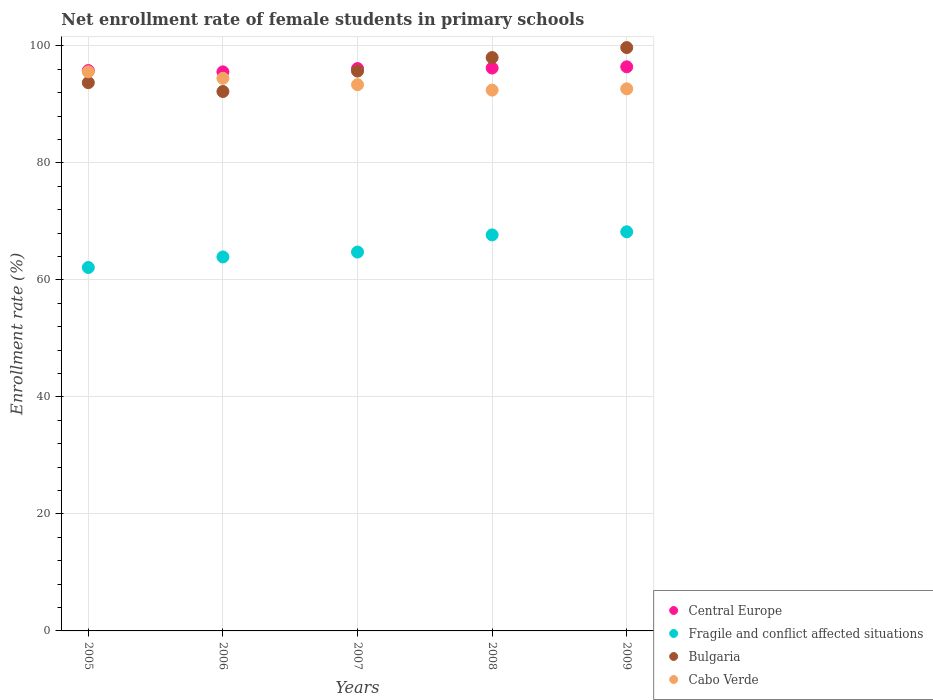How many different coloured dotlines are there?
Offer a terse response. 4. Is the number of dotlines equal to the number of legend labels?
Ensure brevity in your answer.  Yes. What is the net enrollment rate of female students in primary schools in Cabo Verde in 2007?
Ensure brevity in your answer.  93.38. Across all years, what is the maximum net enrollment rate of female students in primary schools in Cabo Verde?
Make the answer very short. 95.59. Across all years, what is the minimum net enrollment rate of female students in primary schools in Cabo Verde?
Your response must be concise. 92.46. In which year was the net enrollment rate of female students in primary schools in Cabo Verde maximum?
Offer a terse response. 2005. What is the total net enrollment rate of female students in primary schools in Bulgaria in the graph?
Your response must be concise. 479.41. What is the difference between the net enrollment rate of female students in primary schools in Cabo Verde in 2006 and that in 2009?
Provide a short and direct response. 1.81. What is the difference between the net enrollment rate of female students in primary schools in Central Europe in 2006 and the net enrollment rate of female students in primary schools in Bulgaria in 2008?
Your response must be concise. -2.45. What is the average net enrollment rate of female students in primary schools in Bulgaria per year?
Keep it short and to the point. 95.88. In the year 2005, what is the difference between the net enrollment rate of female students in primary schools in Cabo Verde and net enrollment rate of female students in primary schools in Central Europe?
Ensure brevity in your answer.  -0.21. What is the ratio of the net enrollment rate of female students in primary schools in Cabo Verde in 2008 to that in 2009?
Keep it short and to the point. 1. Is the difference between the net enrollment rate of female students in primary schools in Cabo Verde in 2005 and 2008 greater than the difference between the net enrollment rate of female students in primary schools in Central Europe in 2005 and 2008?
Offer a very short reply. Yes. What is the difference between the highest and the second highest net enrollment rate of female students in primary schools in Cabo Verde?
Give a very brief answer. 1.11. What is the difference between the highest and the lowest net enrollment rate of female students in primary schools in Fragile and conflict affected situations?
Ensure brevity in your answer.  6.1. Is the net enrollment rate of female students in primary schools in Fragile and conflict affected situations strictly less than the net enrollment rate of female students in primary schools in Bulgaria over the years?
Keep it short and to the point. Yes. How many dotlines are there?
Keep it short and to the point. 4. How many years are there in the graph?
Ensure brevity in your answer.  5. What is the difference between two consecutive major ticks on the Y-axis?
Provide a short and direct response. 20. Are the values on the major ticks of Y-axis written in scientific E-notation?
Ensure brevity in your answer.  No. Does the graph contain any zero values?
Your response must be concise. No. How are the legend labels stacked?
Offer a terse response. Vertical. What is the title of the graph?
Provide a succinct answer. Net enrollment rate of female students in primary schools. Does "Low & middle income" appear as one of the legend labels in the graph?
Your answer should be very brief. No. What is the label or title of the Y-axis?
Your response must be concise. Enrollment rate (%). What is the Enrollment rate (%) of Central Europe in 2005?
Keep it short and to the point. 95.8. What is the Enrollment rate (%) in Fragile and conflict affected situations in 2005?
Provide a succinct answer. 62.13. What is the Enrollment rate (%) of Bulgaria in 2005?
Keep it short and to the point. 93.73. What is the Enrollment rate (%) of Cabo Verde in 2005?
Give a very brief answer. 95.59. What is the Enrollment rate (%) in Central Europe in 2006?
Your answer should be compact. 95.57. What is the Enrollment rate (%) of Fragile and conflict affected situations in 2006?
Provide a succinct answer. 63.93. What is the Enrollment rate (%) in Bulgaria in 2006?
Your answer should be compact. 92.22. What is the Enrollment rate (%) of Cabo Verde in 2006?
Provide a short and direct response. 94.48. What is the Enrollment rate (%) of Central Europe in 2007?
Provide a succinct answer. 96.14. What is the Enrollment rate (%) in Fragile and conflict affected situations in 2007?
Make the answer very short. 64.77. What is the Enrollment rate (%) in Bulgaria in 2007?
Keep it short and to the point. 95.71. What is the Enrollment rate (%) of Cabo Verde in 2007?
Give a very brief answer. 93.38. What is the Enrollment rate (%) of Central Europe in 2008?
Ensure brevity in your answer.  96.23. What is the Enrollment rate (%) of Fragile and conflict affected situations in 2008?
Your answer should be very brief. 67.71. What is the Enrollment rate (%) in Bulgaria in 2008?
Your answer should be very brief. 98.02. What is the Enrollment rate (%) of Cabo Verde in 2008?
Your response must be concise. 92.46. What is the Enrollment rate (%) of Central Europe in 2009?
Your answer should be compact. 96.44. What is the Enrollment rate (%) in Fragile and conflict affected situations in 2009?
Give a very brief answer. 68.23. What is the Enrollment rate (%) in Bulgaria in 2009?
Your answer should be very brief. 99.73. What is the Enrollment rate (%) of Cabo Verde in 2009?
Your answer should be very brief. 92.67. Across all years, what is the maximum Enrollment rate (%) in Central Europe?
Provide a short and direct response. 96.44. Across all years, what is the maximum Enrollment rate (%) in Fragile and conflict affected situations?
Provide a short and direct response. 68.23. Across all years, what is the maximum Enrollment rate (%) of Bulgaria?
Provide a succinct answer. 99.73. Across all years, what is the maximum Enrollment rate (%) in Cabo Verde?
Make the answer very short. 95.59. Across all years, what is the minimum Enrollment rate (%) of Central Europe?
Offer a very short reply. 95.57. Across all years, what is the minimum Enrollment rate (%) of Fragile and conflict affected situations?
Your response must be concise. 62.13. Across all years, what is the minimum Enrollment rate (%) of Bulgaria?
Provide a short and direct response. 92.22. Across all years, what is the minimum Enrollment rate (%) of Cabo Verde?
Provide a succinct answer. 92.46. What is the total Enrollment rate (%) of Central Europe in the graph?
Provide a succinct answer. 480.18. What is the total Enrollment rate (%) of Fragile and conflict affected situations in the graph?
Ensure brevity in your answer.  326.78. What is the total Enrollment rate (%) of Bulgaria in the graph?
Your response must be concise. 479.41. What is the total Enrollment rate (%) of Cabo Verde in the graph?
Provide a short and direct response. 468.57. What is the difference between the Enrollment rate (%) in Central Europe in 2005 and that in 2006?
Ensure brevity in your answer.  0.22. What is the difference between the Enrollment rate (%) of Fragile and conflict affected situations in 2005 and that in 2006?
Your answer should be compact. -1.8. What is the difference between the Enrollment rate (%) of Bulgaria in 2005 and that in 2006?
Ensure brevity in your answer.  1.51. What is the difference between the Enrollment rate (%) in Cabo Verde in 2005 and that in 2006?
Give a very brief answer. 1.11. What is the difference between the Enrollment rate (%) in Central Europe in 2005 and that in 2007?
Offer a terse response. -0.35. What is the difference between the Enrollment rate (%) in Fragile and conflict affected situations in 2005 and that in 2007?
Provide a short and direct response. -2.64. What is the difference between the Enrollment rate (%) of Bulgaria in 2005 and that in 2007?
Provide a succinct answer. -1.98. What is the difference between the Enrollment rate (%) in Cabo Verde in 2005 and that in 2007?
Your answer should be very brief. 2.21. What is the difference between the Enrollment rate (%) of Central Europe in 2005 and that in 2008?
Provide a succinct answer. -0.43. What is the difference between the Enrollment rate (%) of Fragile and conflict affected situations in 2005 and that in 2008?
Offer a very short reply. -5.58. What is the difference between the Enrollment rate (%) in Bulgaria in 2005 and that in 2008?
Ensure brevity in your answer.  -4.29. What is the difference between the Enrollment rate (%) of Cabo Verde in 2005 and that in 2008?
Your response must be concise. 3.13. What is the difference between the Enrollment rate (%) of Central Europe in 2005 and that in 2009?
Your response must be concise. -0.64. What is the difference between the Enrollment rate (%) in Fragile and conflict affected situations in 2005 and that in 2009?
Offer a terse response. -6.1. What is the difference between the Enrollment rate (%) in Bulgaria in 2005 and that in 2009?
Offer a very short reply. -6. What is the difference between the Enrollment rate (%) of Cabo Verde in 2005 and that in 2009?
Your answer should be very brief. 2.91. What is the difference between the Enrollment rate (%) of Central Europe in 2006 and that in 2007?
Keep it short and to the point. -0.57. What is the difference between the Enrollment rate (%) of Fragile and conflict affected situations in 2006 and that in 2007?
Make the answer very short. -0.84. What is the difference between the Enrollment rate (%) in Bulgaria in 2006 and that in 2007?
Your response must be concise. -3.5. What is the difference between the Enrollment rate (%) in Cabo Verde in 2006 and that in 2007?
Your answer should be very brief. 1.1. What is the difference between the Enrollment rate (%) in Central Europe in 2006 and that in 2008?
Keep it short and to the point. -0.65. What is the difference between the Enrollment rate (%) in Fragile and conflict affected situations in 2006 and that in 2008?
Offer a terse response. -3.77. What is the difference between the Enrollment rate (%) in Bulgaria in 2006 and that in 2008?
Keep it short and to the point. -5.8. What is the difference between the Enrollment rate (%) in Cabo Verde in 2006 and that in 2008?
Ensure brevity in your answer.  2.02. What is the difference between the Enrollment rate (%) in Central Europe in 2006 and that in 2009?
Provide a succinct answer. -0.86. What is the difference between the Enrollment rate (%) in Fragile and conflict affected situations in 2006 and that in 2009?
Give a very brief answer. -4.3. What is the difference between the Enrollment rate (%) of Bulgaria in 2006 and that in 2009?
Keep it short and to the point. -7.51. What is the difference between the Enrollment rate (%) in Cabo Verde in 2006 and that in 2009?
Provide a short and direct response. 1.81. What is the difference between the Enrollment rate (%) of Central Europe in 2007 and that in 2008?
Your response must be concise. -0.08. What is the difference between the Enrollment rate (%) in Fragile and conflict affected situations in 2007 and that in 2008?
Make the answer very short. -2.93. What is the difference between the Enrollment rate (%) of Bulgaria in 2007 and that in 2008?
Make the answer very short. -2.31. What is the difference between the Enrollment rate (%) in Cabo Verde in 2007 and that in 2008?
Offer a very short reply. 0.92. What is the difference between the Enrollment rate (%) in Central Europe in 2007 and that in 2009?
Keep it short and to the point. -0.3. What is the difference between the Enrollment rate (%) of Fragile and conflict affected situations in 2007 and that in 2009?
Your answer should be compact. -3.46. What is the difference between the Enrollment rate (%) in Bulgaria in 2007 and that in 2009?
Ensure brevity in your answer.  -4.02. What is the difference between the Enrollment rate (%) of Cabo Verde in 2007 and that in 2009?
Offer a terse response. 0.71. What is the difference between the Enrollment rate (%) of Central Europe in 2008 and that in 2009?
Your answer should be compact. -0.21. What is the difference between the Enrollment rate (%) in Fragile and conflict affected situations in 2008 and that in 2009?
Ensure brevity in your answer.  -0.53. What is the difference between the Enrollment rate (%) in Bulgaria in 2008 and that in 2009?
Your answer should be compact. -1.71. What is the difference between the Enrollment rate (%) of Cabo Verde in 2008 and that in 2009?
Ensure brevity in your answer.  -0.22. What is the difference between the Enrollment rate (%) of Central Europe in 2005 and the Enrollment rate (%) of Fragile and conflict affected situations in 2006?
Your answer should be very brief. 31.86. What is the difference between the Enrollment rate (%) in Central Europe in 2005 and the Enrollment rate (%) in Bulgaria in 2006?
Make the answer very short. 3.58. What is the difference between the Enrollment rate (%) of Central Europe in 2005 and the Enrollment rate (%) of Cabo Verde in 2006?
Give a very brief answer. 1.32. What is the difference between the Enrollment rate (%) of Fragile and conflict affected situations in 2005 and the Enrollment rate (%) of Bulgaria in 2006?
Give a very brief answer. -30.09. What is the difference between the Enrollment rate (%) of Fragile and conflict affected situations in 2005 and the Enrollment rate (%) of Cabo Verde in 2006?
Keep it short and to the point. -32.35. What is the difference between the Enrollment rate (%) in Bulgaria in 2005 and the Enrollment rate (%) in Cabo Verde in 2006?
Provide a short and direct response. -0.75. What is the difference between the Enrollment rate (%) of Central Europe in 2005 and the Enrollment rate (%) of Fragile and conflict affected situations in 2007?
Your answer should be compact. 31.02. What is the difference between the Enrollment rate (%) in Central Europe in 2005 and the Enrollment rate (%) in Bulgaria in 2007?
Offer a terse response. 0.08. What is the difference between the Enrollment rate (%) of Central Europe in 2005 and the Enrollment rate (%) of Cabo Verde in 2007?
Ensure brevity in your answer.  2.42. What is the difference between the Enrollment rate (%) of Fragile and conflict affected situations in 2005 and the Enrollment rate (%) of Bulgaria in 2007?
Offer a very short reply. -33.58. What is the difference between the Enrollment rate (%) in Fragile and conflict affected situations in 2005 and the Enrollment rate (%) in Cabo Verde in 2007?
Your response must be concise. -31.25. What is the difference between the Enrollment rate (%) in Central Europe in 2005 and the Enrollment rate (%) in Fragile and conflict affected situations in 2008?
Your response must be concise. 28.09. What is the difference between the Enrollment rate (%) of Central Europe in 2005 and the Enrollment rate (%) of Bulgaria in 2008?
Provide a succinct answer. -2.22. What is the difference between the Enrollment rate (%) of Central Europe in 2005 and the Enrollment rate (%) of Cabo Verde in 2008?
Offer a very short reply. 3.34. What is the difference between the Enrollment rate (%) of Fragile and conflict affected situations in 2005 and the Enrollment rate (%) of Bulgaria in 2008?
Your answer should be compact. -35.89. What is the difference between the Enrollment rate (%) in Fragile and conflict affected situations in 2005 and the Enrollment rate (%) in Cabo Verde in 2008?
Your answer should be compact. -30.32. What is the difference between the Enrollment rate (%) in Bulgaria in 2005 and the Enrollment rate (%) in Cabo Verde in 2008?
Keep it short and to the point. 1.27. What is the difference between the Enrollment rate (%) of Central Europe in 2005 and the Enrollment rate (%) of Fragile and conflict affected situations in 2009?
Your answer should be compact. 27.56. What is the difference between the Enrollment rate (%) of Central Europe in 2005 and the Enrollment rate (%) of Bulgaria in 2009?
Ensure brevity in your answer.  -3.93. What is the difference between the Enrollment rate (%) of Central Europe in 2005 and the Enrollment rate (%) of Cabo Verde in 2009?
Ensure brevity in your answer.  3.12. What is the difference between the Enrollment rate (%) in Fragile and conflict affected situations in 2005 and the Enrollment rate (%) in Bulgaria in 2009?
Give a very brief answer. -37.6. What is the difference between the Enrollment rate (%) of Fragile and conflict affected situations in 2005 and the Enrollment rate (%) of Cabo Verde in 2009?
Your response must be concise. -30.54. What is the difference between the Enrollment rate (%) of Bulgaria in 2005 and the Enrollment rate (%) of Cabo Verde in 2009?
Ensure brevity in your answer.  1.06. What is the difference between the Enrollment rate (%) of Central Europe in 2006 and the Enrollment rate (%) of Fragile and conflict affected situations in 2007?
Make the answer very short. 30.8. What is the difference between the Enrollment rate (%) of Central Europe in 2006 and the Enrollment rate (%) of Bulgaria in 2007?
Your answer should be compact. -0.14. What is the difference between the Enrollment rate (%) in Central Europe in 2006 and the Enrollment rate (%) in Cabo Verde in 2007?
Ensure brevity in your answer.  2.19. What is the difference between the Enrollment rate (%) of Fragile and conflict affected situations in 2006 and the Enrollment rate (%) of Bulgaria in 2007?
Keep it short and to the point. -31.78. What is the difference between the Enrollment rate (%) in Fragile and conflict affected situations in 2006 and the Enrollment rate (%) in Cabo Verde in 2007?
Your answer should be very brief. -29.45. What is the difference between the Enrollment rate (%) in Bulgaria in 2006 and the Enrollment rate (%) in Cabo Verde in 2007?
Your response must be concise. -1.16. What is the difference between the Enrollment rate (%) of Central Europe in 2006 and the Enrollment rate (%) of Fragile and conflict affected situations in 2008?
Provide a short and direct response. 27.87. What is the difference between the Enrollment rate (%) in Central Europe in 2006 and the Enrollment rate (%) in Bulgaria in 2008?
Ensure brevity in your answer.  -2.45. What is the difference between the Enrollment rate (%) of Central Europe in 2006 and the Enrollment rate (%) of Cabo Verde in 2008?
Give a very brief answer. 3.12. What is the difference between the Enrollment rate (%) of Fragile and conflict affected situations in 2006 and the Enrollment rate (%) of Bulgaria in 2008?
Offer a terse response. -34.09. What is the difference between the Enrollment rate (%) of Fragile and conflict affected situations in 2006 and the Enrollment rate (%) of Cabo Verde in 2008?
Your answer should be very brief. -28.52. What is the difference between the Enrollment rate (%) of Bulgaria in 2006 and the Enrollment rate (%) of Cabo Verde in 2008?
Your answer should be very brief. -0.24. What is the difference between the Enrollment rate (%) in Central Europe in 2006 and the Enrollment rate (%) in Fragile and conflict affected situations in 2009?
Provide a succinct answer. 27.34. What is the difference between the Enrollment rate (%) in Central Europe in 2006 and the Enrollment rate (%) in Bulgaria in 2009?
Provide a succinct answer. -4.15. What is the difference between the Enrollment rate (%) in Central Europe in 2006 and the Enrollment rate (%) in Cabo Verde in 2009?
Offer a terse response. 2.9. What is the difference between the Enrollment rate (%) of Fragile and conflict affected situations in 2006 and the Enrollment rate (%) of Bulgaria in 2009?
Offer a terse response. -35.79. What is the difference between the Enrollment rate (%) in Fragile and conflict affected situations in 2006 and the Enrollment rate (%) in Cabo Verde in 2009?
Offer a terse response. -28.74. What is the difference between the Enrollment rate (%) in Bulgaria in 2006 and the Enrollment rate (%) in Cabo Verde in 2009?
Offer a very short reply. -0.46. What is the difference between the Enrollment rate (%) of Central Europe in 2007 and the Enrollment rate (%) of Fragile and conflict affected situations in 2008?
Your answer should be very brief. 28.44. What is the difference between the Enrollment rate (%) in Central Europe in 2007 and the Enrollment rate (%) in Bulgaria in 2008?
Provide a succinct answer. -1.88. What is the difference between the Enrollment rate (%) in Central Europe in 2007 and the Enrollment rate (%) in Cabo Verde in 2008?
Keep it short and to the point. 3.69. What is the difference between the Enrollment rate (%) in Fragile and conflict affected situations in 2007 and the Enrollment rate (%) in Bulgaria in 2008?
Give a very brief answer. -33.25. What is the difference between the Enrollment rate (%) in Fragile and conflict affected situations in 2007 and the Enrollment rate (%) in Cabo Verde in 2008?
Your response must be concise. -27.68. What is the difference between the Enrollment rate (%) of Bulgaria in 2007 and the Enrollment rate (%) of Cabo Verde in 2008?
Offer a terse response. 3.26. What is the difference between the Enrollment rate (%) of Central Europe in 2007 and the Enrollment rate (%) of Fragile and conflict affected situations in 2009?
Offer a terse response. 27.91. What is the difference between the Enrollment rate (%) of Central Europe in 2007 and the Enrollment rate (%) of Bulgaria in 2009?
Offer a terse response. -3.59. What is the difference between the Enrollment rate (%) of Central Europe in 2007 and the Enrollment rate (%) of Cabo Verde in 2009?
Provide a short and direct response. 3.47. What is the difference between the Enrollment rate (%) in Fragile and conflict affected situations in 2007 and the Enrollment rate (%) in Bulgaria in 2009?
Provide a succinct answer. -34.96. What is the difference between the Enrollment rate (%) of Fragile and conflict affected situations in 2007 and the Enrollment rate (%) of Cabo Verde in 2009?
Your answer should be very brief. -27.9. What is the difference between the Enrollment rate (%) in Bulgaria in 2007 and the Enrollment rate (%) in Cabo Verde in 2009?
Ensure brevity in your answer.  3.04. What is the difference between the Enrollment rate (%) in Central Europe in 2008 and the Enrollment rate (%) in Fragile and conflict affected situations in 2009?
Provide a succinct answer. 27.99. What is the difference between the Enrollment rate (%) in Central Europe in 2008 and the Enrollment rate (%) in Bulgaria in 2009?
Your answer should be very brief. -3.5. What is the difference between the Enrollment rate (%) of Central Europe in 2008 and the Enrollment rate (%) of Cabo Verde in 2009?
Ensure brevity in your answer.  3.55. What is the difference between the Enrollment rate (%) in Fragile and conflict affected situations in 2008 and the Enrollment rate (%) in Bulgaria in 2009?
Give a very brief answer. -32.02. What is the difference between the Enrollment rate (%) in Fragile and conflict affected situations in 2008 and the Enrollment rate (%) in Cabo Verde in 2009?
Offer a terse response. -24.97. What is the difference between the Enrollment rate (%) in Bulgaria in 2008 and the Enrollment rate (%) in Cabo Verde in 2009?
Provide a short and direct response. 5.35. What is the average Enrollment rate (%) of Central Europe per year?
Your answer should be compact. 96.04. What is the average Enrollment rate (%) in Fragile and conflict affected situations per year?
Keep it short and to the point. 65.36. What is the average Enrollment rate (%) in Bulgaria per year?
Your answer should be very brief. 95.88. What is the average Enrollment rate (%) of Cabo Verde per year?
Offer a very short reply. 93.71. In the year 2005, what is the difference between the Enrollment rate (%) in Central Europe and Enrollment rate (%) in Fragile and conflict affected situations?
Your response must be concise. 33.67. In the year 2005, what is the difference between the Enrollment rate (%) in Central Europe and Enrollment rate (%) in Bulgaria?
Provide a succinct answer. 2.07. In the year 2005, what is the difference between the Enrollment rate (%) in Central Europe and Enrollment rate (%) in Cabo Verde?
Your response must be concise. 0.21. In the year 2005, what is the difference between the Enrollment rate (%) of Fragile and conflict affected situations and Enrollment rate (%) of Bulgaria?
Your response must be concise. -31.6. In the year 2005, what is the difference between the Enrollment rate (%) in Fragile and conflict affected situations and Enrollment rate (%) in Cabo Verde?
Your answer should be very brief. -33.46. In the year 2005, what is the difference between the Enrollment rate (%) of Bulgaria and Enrollment rate (%) of Cabo Verde?
Ensure brevity in your answer.  -1.86. In the year 2006, what is the difference between the Enrollment rate (%) of Central Europe and Enrollment rate (%) of Fragile and conflict affected situations?
Your response must be concise. 31.64. In the year 2006, what is the difference between the Enrollment rate (%) of Central Europe and Enrollment rate (%) of Bulgaria?
Make the answer very short. 3.36. In the year 2006, what is the difference between the Enrollment rate (%) of Central Europe and Enrollment rate (%) of Cabo Verde?
Your answer should be compact. 1.09. In the year 2006, what is the difference between the Enrollment rate (%) of Fragile and conflict affected situations and Enrollment rate (%) of Bulgaria?
Provide a short and direct response. -28.28. In the year 2006, what is the difference between the Enrollment rate (%) of Fragile and conflict affected situations and Enrollment rate (%) of Cabo Verde?
Give a very brief answer. -30.55. In the year 2006, what is the difference between the Enrollment rate (%) in Bulgaria and Enrollment rate (%) in Cabo Verde?
Your answer should be compact. -2.26. In the year 2007, what is the difference between the Enrollment rate (%) in Central Europe and Enrollment rate (%) in Fragile and conflict affected situations?
Offer a very short reply. 31.37. In the year 2007, what is the difference between the Enrollment rate (%) of Central Europe and Enrollment rate (%) of Bulgaria?
Your response must be concise. 0.43. In the year 2007, what is the difference between the Enrollment rate (%) in Central Europe and Enrollment rate (%) in Cabo Verde?
Your answer should be very brief. 2.76. In the year 2007, what is the difference between the Enrollment rate (%) in Fragile and conflict affected situations and Enrollment rate (%) in Bulgaria?
Your response must be concise. -30.94. In the year 2007, what is the difference between the Enrollment rate (%) in Fragile and conflict affected situations and Enrollment rate (%) in Cabo Verde?
Offer a very short reply. -28.61. In the year 2007, what is the difference between the Enrollment rate (%) in Bulgaria and Enrollment rate (%) in Cabo Verde?
Offer a very short reply. 2.33. In the year 2008, what is the difference between the Enrollment rate (%) in Central Europe and Enrollment rate (%) in Fragile and conflict affected situations?
Offer a very short reply. 28.52. In the year 2008, what is the difference between the Enrollment rate (%) in Central Europe and Enrollment rate (%) in Bulgaria?
Offer a very short reply. -1.79. In the year 2008, what is the difference between the Enrollment rate (%) in Central Europe and Enrollment rate (%) in Cabo Verde?
Give a very brief answer. 3.77. In the year 2008, what is the difference between the Enrollment rate (%) in Fragile and conflict affected situations and Enrollment rate (%) in Bulgaria?
Give a very brief answer. -30.32. In the year 2008, what is the difference between the Enrollment rate (%) in Fragile and conflict affected situations and Enrollment rate (%) in Cabo Verde?
Provide a succinct answer. -24.75. In the year 2008, what is the difference between the Enrollment rate (%) in Bulgaria and Enrollment rate (%) in Cabo Verde?
Offer a very short reply. 5.57. In the year 2009, what is the difference between the Enrollment rate (%) in Central Europe and Enrollment rate (%) in Fragile and conflict affected situations?
Offer a very short reply. 28.2. In the year 2009, what is the difference between the Enrollment rate (%) in Central Europe and Enrollment rate (%) in Bulgaria?
Offer a terse response. -3.29. In the year 2009, what is the difference between the Enrollment rate (%) of Central Europe and Enrollment rate (%) of Cabo Verde?
Offer a very short reply. 3.77. In the year 2009, what is the difference between the Enrollment rate (%) in Fragile and conflict affected situations and Enrollment rate (%) in Bulgaria?
Your answer should be compact. -31.49. In the year 2009, what is the difference between the Enrollment rate (%) of Fragile and conflict affected situations and Enrollment rate (%) of Cabo Verde?
Provide a short and direct response. -24.44. In the year 2009, what is the difference between the Enrollment rate (%) of Bulgaria and Enrollment rate (%) of Cabo Verde?
Make the answer very short. 7.06. What is the ratio of the Enrollment rate (%) in Fragile and conflict affected situations in 2005 to that in 2006?
Provide a short and direct response. 0.97. What is the ratio of the Enrollment rate (%) in Bulgaria in 2005 to that in 2006?
Ensure brevity in your answer.  1.02. What is the ratio of the Enrollment rate (%) in Cabo Verde in 2005 to that in 2006?
Keep it short and to the point. 1.01. What is the ratio of the Enrollment rate (%) of Fragile and conflict affected situations in 2005 to that in 2007?
Provide a short and direct response. 0.96. What is the ratio of the Enrollment rate (%) of Bulgaria in 2005 to that in 2007?
Offer a very short reply. 0.98. What is the ratio of the Enrollment rate (%) in Cabo Verde in 2005 to that in 2007?
Your answer should be compact. 1.02. What is the ratio of the Enrollment rate (%) in Fragile and conflict affected situations in 2005 to that in 2008?
Ensure brevity in your answer.  0.92. What is the ratio of the Enrollment rate (%) in Bulgaria in 2005 to that in 2008?
Offer a terse response. 0.96. What is the ratio of the Enrollment rate (%) in Cabo Verde in 2005 to that in 2008?
Offer a very short reply. 1.03. What is the ratio of the Enrollment rate (%) in Fragile and conflict affected situations in 2005 to that in 2009?
Offer a very short reply. 0.91. What is the ratio of the Enrollment rate (%) of Bulgaria in 2005 to that in 2009?
Offer a terse response. 0.94. What is the ratio of the Enrollment rate (%) in Cabo Verde in 2005 to that in 2009?
Provide a succinct answer. 1.03. What is the ratio of the Enrollment rate (%) in Central Europe in 2006 to that in 2007?
Provide a succinct answer. 0.99. What is the ratio of the Enrollment rate (%) of Fragile and conflict affected situations in 2006 to that in 2007?
Offer a terse response. 0.99. What is the ratio of the Enrollment rate (%) of Bulgaria in 2006 to that in 2007?
Offer a very short reply. 0.96. What is the ratio of the Enrollment rate (%) of Cabo Verde in 2006 to that in 2007?
Your answer should be compact. 1.01. What is the ratio of the Enrollment rate (%) of Fragile and conflict affected situations in 2006 to that in 2008?
Offer a very short reply. 0.94. What is the ratio of the Enrollment rate (%) in Bulgaria in 2006 to that in 2008?
Offer a terse response. 0.94. What is the ratio of the Enrollment rate (%) of Cabo Verde in 2006 to that in 2008?
Provide a short and direct response. 1.02. What is the ratio of the Enrollment rate (%) of Fragile and conflict affected situations in 2006 to that in 2009?
Make the answer very short. 0.94. What is the ratio of the Enrollment rate (%) of Bulgaria in 2006 to that in 2009?
Make the answer very short. 0.92. What is the ratio of the Enrollment rate (%) of Cabo Verde in 2006 to that in 2009?
Provide a short and direct response. 1.02. What is the ratio of the Enrollment rate (%) in Central Europe in 2007 to that in 2008?
Your answer should be very brief. 1. What is the ratio of the Enrollment rate (%) in Fragile and conflict affected situations in 2007 to that in 2008?
Your response must be concise. 0.96. What is the ratio of the Enrollment rate (%) in Bulgaria in 2007 to that in 2008?
Offer a very short reply. 0.98. What is the ratio of the Enrollment rate (%) of Central Europe in 2007 to that in 2009?
Your answer should be very brief. 1. What is the ratio of the Enrollment rate (%) of Fragile and conflict affected situations in 2007 to that in 2009?
Keep it short and to the point. 0.95. What is the ratio of the Enrollment rate (%) of Bulgaria in 2007 to that in 2009?
Offer a very short reply. 0.96. What is the ratio of the Enrollment rate (%) in Cabo Verde in 2007 to that in 2009?
Provide a short and direct response. 1.01. What is the ratio of the Enrollment rate (%) of Central Europe in 2008 to that in 2009?
Your answer should be very brief. 1. What is the ratio of the Enrollment rate (%) in Bulgaria in 2008 to that in 2009?
Your answer should be compact. 0.98. What is the ratio of the Enrollment rate (%) in Cabo Verde in 2008 to that in 2009?
Offer a terse response. 1. What is the difference between the highest and the second highest Enrollment rate (%) in Central Europe?
Your answer should be compact. 0.21. What is the difference between the highest and the second highest Enrollment rate (%) in Fragile and conflict affected situations?
Make the answer very short. 0.53. What is the difference between the highest and the second highest Enrollment rate (%) of Bulgaria?
Your response must be concise. 1.71. What is the difference between the highest and the second highest Enrollment rate (%) in Cabo Verde?
Make the answer very short. 1.11. What is the difference between the highest and the lowest Enrollment rate (%) of Central Europe?
Make the answer very short. 0.86. What is the difference between the highest and the lowest Enrollment rate (%) of Fragile and conflict affected situations?
Make the answer very short. 6.1. What is the difference between the highest and the lowest Enrollment rate (%) in Bulgaria?
Give a very brief answer. 7.51. What is the difference between the highest and the lowest Enrollment rate (%) in Cabo Verde?
Ensure brevity in your answer.  3.13. 